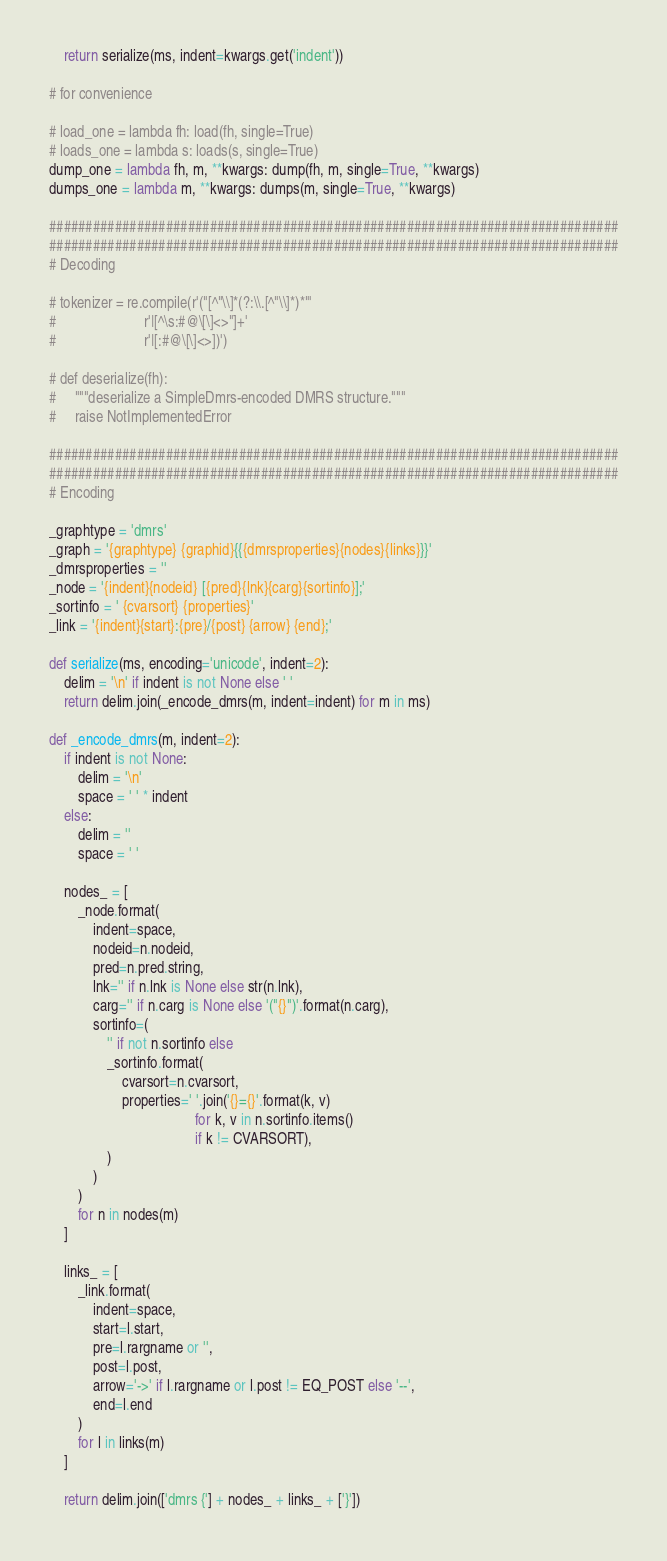<code> <loc_0><loc_0><loc_500><loc_500><_Python_>    return serialize(ms, indent=kwargs.get('indent'))

# for convenience

# load_one = lambda fh: load(fh, single=True)
# loads_one = lambda s: loads(s, single=True)
dump_one = lambda fh, m, **kwargs: dump(fh, m, single=True, **kwargs)
dumps_one = lambda m, **kwargs: dumps(m, single=True, **kwargs)

##############################################################################
##############################################################################
# Decoding

# tokenizer = re.compile(r'("[^"\\]*(?:\\.[^"\\]*)*"'
#                        r'|[^\s:#@\[\]<>"]+'
#                        r'|[:#@\[\]<>])')

# def deserialize(fh):
#     """deserialize a SimpleDmrs-encoded DMRS structure."""
#     raise NotImplementedError

##############################################################################
##############################################################################
# Encoding

_graphtype = 'dmrs'
_graph = '{graphtype} {graphid}{{{dmrsproperties}{nodes}{links}}}'
_dmrsproperties = ''
_node = '{indent}{nodeid} [{pred}{lnk}{carg}{sortinfo}];'
_sortinfo = ' {cvarsort} {properties}'
_link = '{indent}{start}:{pre}/{post} {arrow} {end};'

def serialize(ms, encoding='unicode', indent=2):
    delim = '\n' if indent is not None else ' '
    return delim.join(_encode_dmrs(m, indent=indent) for m in ms)

def _encode_dmrs(m, indent=2):
    if indent is not None:
        delim = '\n'
        space = ' ' * indent
    else:
        delim = ''
        space = ' '

    nodes_ = [
        _node.format(
            indent=space,
            nodeid=n.nodeid,
            pred=n.pred.string,
            lnk='' if n.lnk is None else str(n.lnk),
            carg='' if n.carg is None else '("{}")'.format(n.carg),
            sortinfo=(
                '' if not n.sortinfo else
                _sortinfo.format(
                    cvarsort=n.cvarsort,
                    properties=' '.join('{}={}'.format(k, v)
                                        for k, v in n.sortinfo.items()
                                        if k != CVARSORT),
                )
            )
        )
        for n in nodes(m)
    ]

    links_ = [
        _link.format(
            indent=space,
            start=l.start,
            pre=l.rargname or '',
            post=l.post,
            arrow='->' if l.rargname or l.post != EQ_POST else '--',
            end=l.end
        )
        for l in links(m)
    ]

    return delim.join(['dmrs {'] + nodes_ + links_ + ['}'])
</code> 